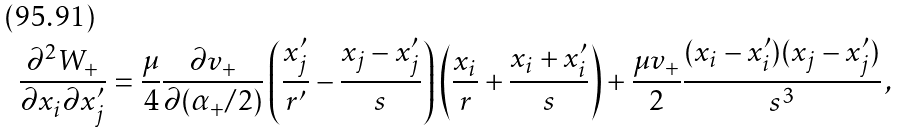Convert formula to latex. <formula><loc_0><loc_0><loc_500><loc_500>\frac { \partial ^ { 2 } W _ { + } } { \partial x _ { i } \partial x _ { j } ^ { \prime } } = \frac { \mu } { 4 } \frac { \partial v _ { + } } { \partial ( \alpha _ { + } / 2 ) } \left ( \frac { x _ { j } ^ { \prime } } { r ^ { \prime } } - \frac { x _ { j } - x _ { j } ^ { \prime } } { s } \right ) \left ( \frac { x _ { i } } { r } + \frac { x _ { i } + x _ { i } ^ { \prime } } { s } \right ) + \frac { \mu v _ { + } } { 2 } \frac { ( x _ { i } - x _ { i } ^ { \prime } ) ( x _ { j } - x _ { j } ^ { \prime } ) } { s ^ { 3 } } \, ,</formula> 